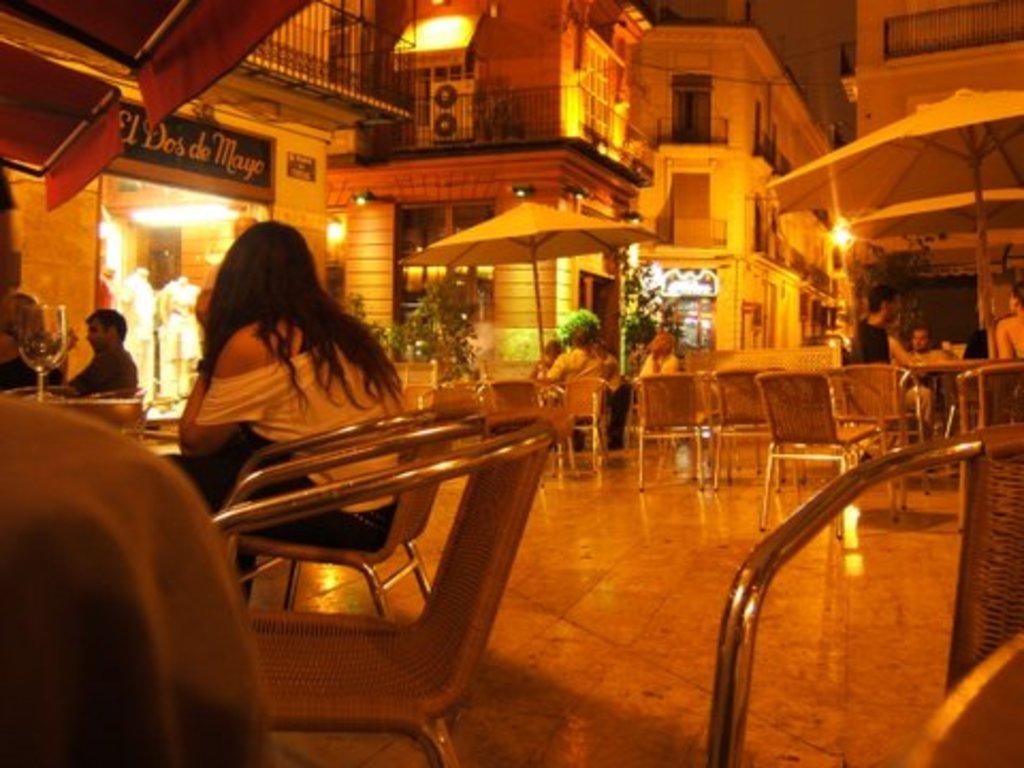Can you describe this image briefly? In this picture we can see there are groups of people sitting on chairs and in front of the people there are tables and on the table there is a glass and behind the people there are buildings and lights. 